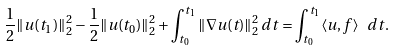Convert formula to latex. <formula><loc_0><loc_0><loc_500><loc_500>\frac { 1 } { 2 } \| u ( t _ { 1 } ) \| _ { 2 } ^ { 2 } - \frac { 1 } { 2 } \| u ( t _ { 0 } ) \| _ { 2 } ^ { 2 } + \int _ { t _ { 0 } } ^ { t _ { 1 } } \| \nabla u ( t ) \| _ { 2 } ^ { 2 } \, d t = \int _ { t _ { 0 } } ^ { t _ { 1 } } \langle u , f \rangle \ \, d t .</formula> 